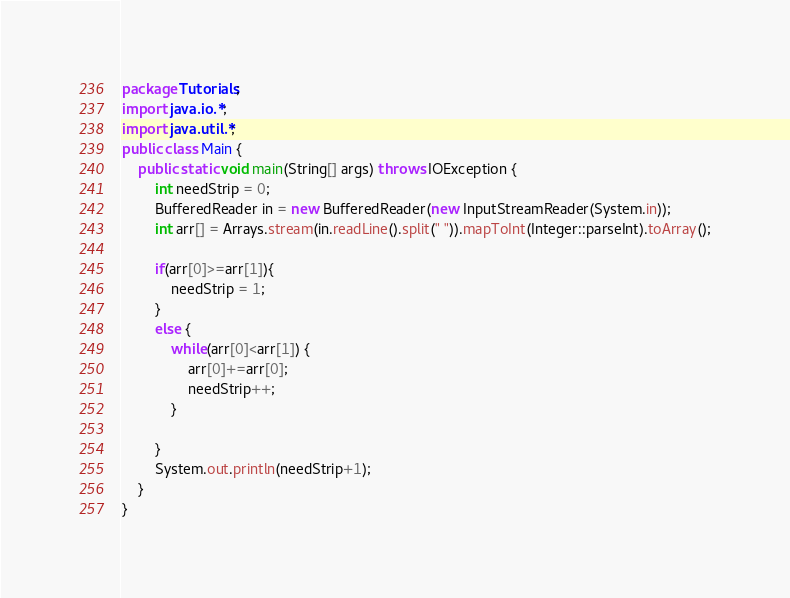<code> <loc_0><loc_0><loc_500><loc_500><_Java_>package Tutorials;
import java.io.*;
import java.util.*;
public class Main {
    public static void main(String[] args) throws IOException {
        int needStrip = 0;
        BufferedReader in = new BufferedReader(new InputStreamReader(System.in));
        int arr[] = Arrays.stream(in.readLine().split(" ")).mapToInt(Integer::parseInt).toArray();
        
        if(arr[0]>=arr[1]){
            needStrip = 1;
        }
        else {
            while(arr[0]<arr[1]) {
                arr[0]+=arr[0];
                needStrip++;
            }

        }
        System.out.println(needStrip+1);
    }
}</code> 